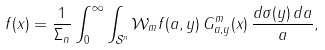<formula> <loc_0><loc_0><loc_500><loc_500>f ( x ) = \frac { 1 } { \Sigma _ { n } } \int _ { 0 } ^ { \infty } \int _ { \mathcal { S } ^ { n } } \mathcal { W } _ { m } f ( a , y ) \, G _ { a , y } ^ { m } ( x ) \, \frac { d \sigma ( y ) \, d a } { a } ,</formula> 